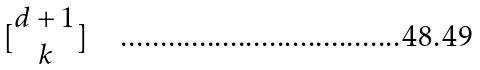Convert formula to latex. <formula><loc_0><loc_0><loc_500><loc_500>[ \begin{matrix} d + 1 \\ k \end{matrix} ]</formula> 